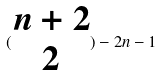Convert formula to latex. <formula><loc_0><loc_0><loc_500><loc_500>( \begin{matrix} n + 2 \\ 2 \end{matrix} ) - 2 n - 1</formula> 